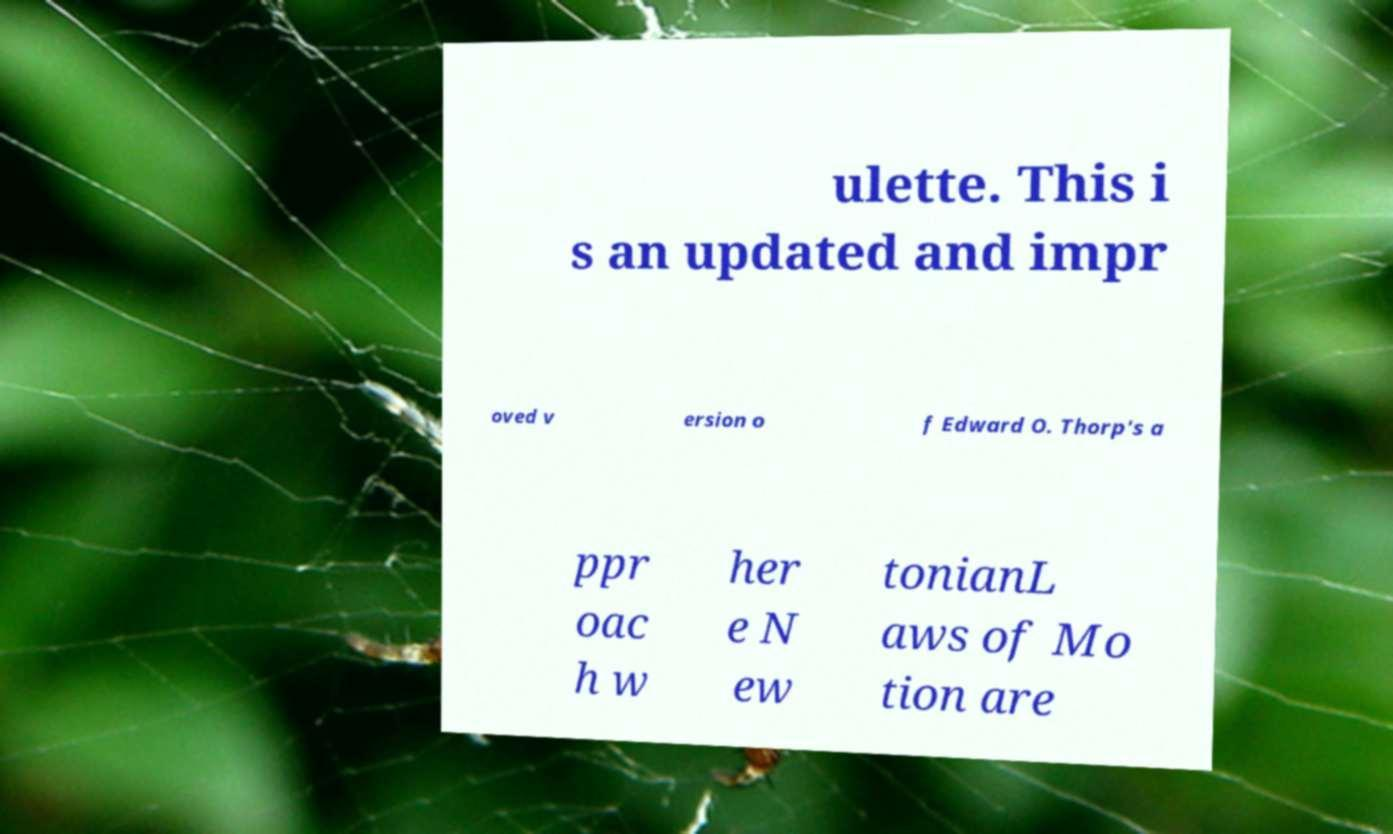I need the written content from this picture converted into text. Can you do that? ulette. This i s an updated and impr oved v ersion o f Edward O. Thorp's a ppr oac h w her e N ew tonianL aws of Mo tion are 